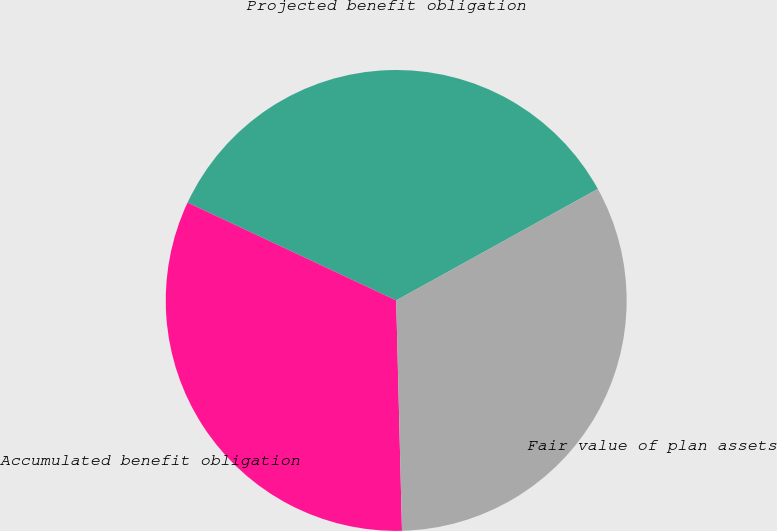<chart> <loc_0><loc_0><loc_500><loc_500><pie_chart><fcel>Projected benefit obligation<fcel>Accumulated benefit obligation<fcel>Fair value of plan assets<nl><fcel>34.98%<fcel>32.38%<fcel>32.64%<nl></chart> 